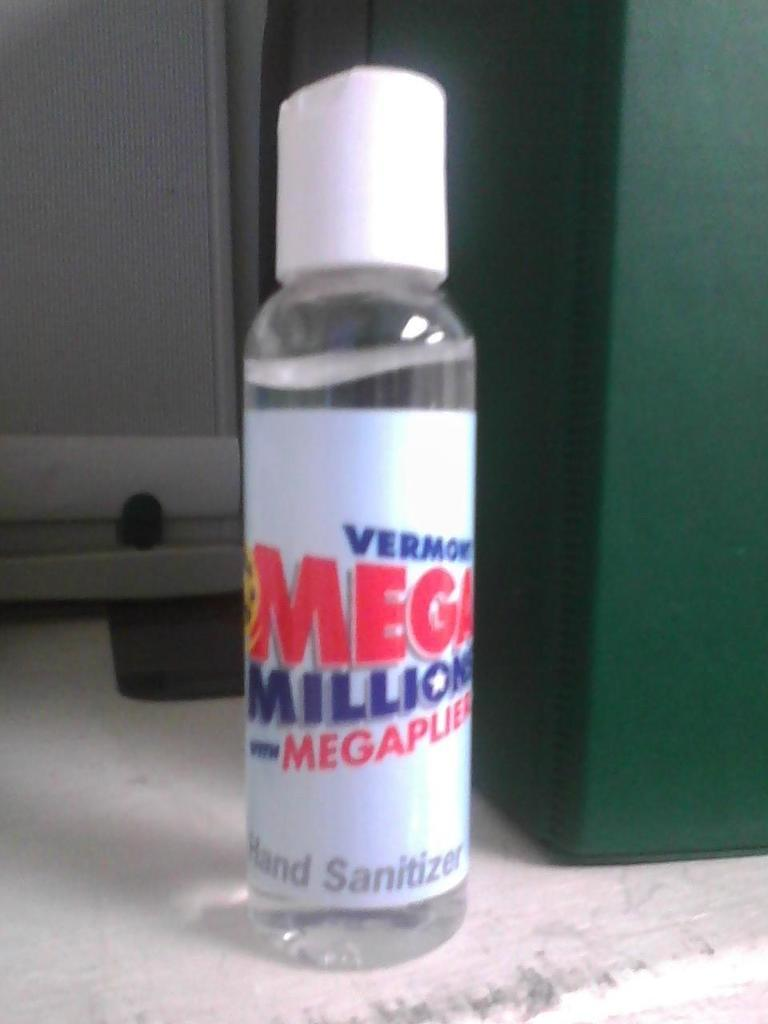Provide a one-sentence caption for the provided image. A white and clear bottle of mega millions hand sanitizer. 